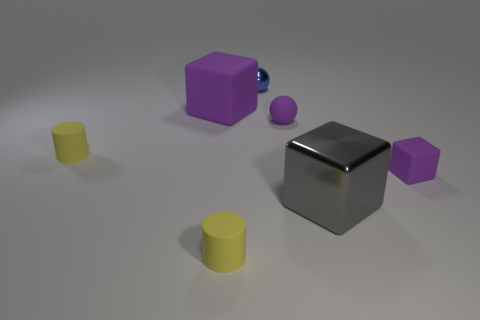Add 2 tiny cylinders. How many objects exist? 9 Subtract all cubes. How many objects are left? 4 Add 4 large cyan shiny things. How many large cyan shiny things exist? 4 Subtract 1 blue spheres. How many objects are left? 6 Subtract all cubes. Subtract all tiny blue balls. How many objects are left? 3 Add 1 gray things. How many gray things are left? 2 